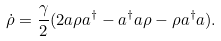<formula> <loc_0><loc_0><loc_500><loc_500>\dot { \rho } = \frac { \gamma } { 2 } ( 2 a \rho a ^ { \dagger } - a ^ { \dagger } a \rho - \rho a ^ { \dagger } a ) .</formula> 